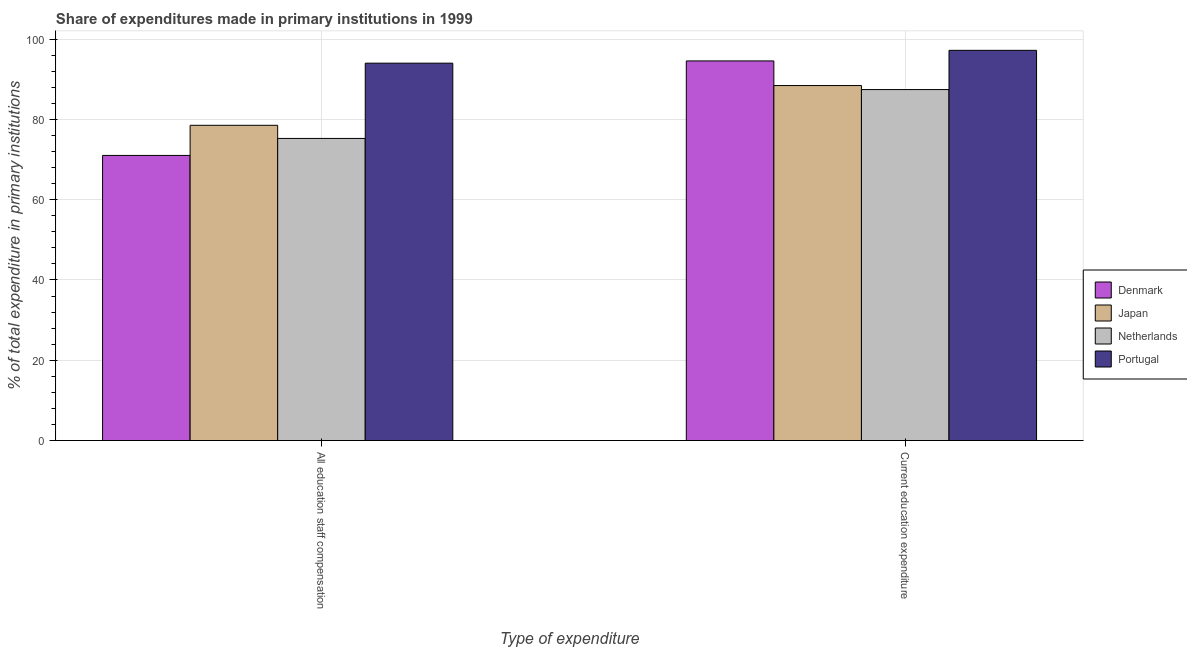How many different coloured bars are there?
Give a very brief answer. 4. How many groups of bars are there?
Offer a terse response. 2. Are the number of bars per tick equal to the number of legend labels?
Give a very brief answer. Yes. Are the number of bars on each tick of the X-axis equal?
Ensure brevity in your answer.  Yes. How many bars are there on the 2nd tick from the left?
Your answer should be very brief. 4. How many bars are there on the 1st tick from the right?
Offer a very short reply. 4. What is the label of the 2nd group of bars from the left?
Your answer should be compact. Current education expenditure. What is the expenditure in education in Portugal?
Offer a very short reply. 97.19. Across all countries, what is the maximum expenditure in staff compensation?
Give a very brief answer. 93.99. Across all countries, what is the minimum expenditure in staff compensation?
Provide a succinct answer. 71.01. In which country was the expenditure in staff compensation maximum?
Give a very brief answer. Portugal. What is the total expenditure in education in the graph?
Offer a very short reply. 367.57. What is the difference between the expenditure in education in Portugal and that in Denmark?
Provide a short and direct response. 2.64. What is the difference between the expenditure in education in Portugal and the expenditure in staff compensation in Denmark?
Your response must be concise. 26.17. What is the average expenditure in staff compensation per country?
Offer a terse response. 79.69. What is the difference between the expenditure in education and expenditure in staff compensation in Portugal?
Your answer should be very brief. 3.19. In how many countries, is the expenditure in education greater than 12 %?
Ensure brevity in your answer.  4. What is the ratio of the expenditure in education in Japan to that in Denmark?
Provide a short and direct response. 0.94. Is the expenditure in education in Denmark less than that in Japan?
Offer a very short reply. No. What does the 1st bar from the left in Current education expenditure represents?
Your answer should be very brief. Denmark. What does the 4th bar from the right in All education staff compensation represents?
Provide a short and direct response. Denmark. How many bars are there?
Your answer should be compact. 8. Does the graph contain any zero values?
Offer a terse response. No. Does the graph contain grids?
Provide a short and direct response. Yes. Where does the legend appear in the graph?
Your answer should be very brief. Center right. How many legend labels are there?
Provide a succinct answer. 4. What is the title of the graph?
Your answer should be very brief. Share of expenditures made in primary institutions in 1999. Does "Latin America(all income levels)" appear as one of the legend labels in the graph?
Keep it short and to the point. No. What is the label or title of the X-axis?
Keep it short and to the point. Type of expenditure. What is the label or title of the Y-axis?
Provide a short and direct response. % of total expenditure in primary institutions. What is the % of total expenditure in primary institutions of Denmark in All education staff compensation?
Your answer should be very brief. 71.01. What is the % of total expenditure in primary institutions in Japan in All education staff compensation?
Offer a very short reply. 78.52. What is the % of total expenditure in primary institutions of Netherlands in All education staff compensation?
Keep it short and to the point. 75.25. What is the % of total expenditure in primary institutions of Portugal in All education staff compensation?
Your answer should be compact. 93.99. What is the % of total expenditure in primary institutions in Denmark in Current education expenditure?
Offer a very short reply. 94.55. What is the % of total expenditure in primary institutions of Japan in Current education expenditure?
Make the answer very short. 88.42. What is the % of total expenditure in primary institutions of Netherlands in Current education expenditure?
Keep it short and to the point. 87.41. What is the % of total expenditure in primary institutions of Portugal in Current education expenditure?
Your answer should be very brief. 97.19. Across all Type of expenditure, what is the maximum % of total expenditure in primary institutions in Denmark?
Keep it short and to the point. 94.55. Across all Type of expenditure, what is the maximum % of total expenditure in primary institutions in Japan?
Keep it short and to the point. 88.42. Across all Type of expenditure, what is the maximum % of total expenditure in primary institutions in Netherlands?
Give a very brief answer. 87.41. Across all Type of expenditure, what is the maximum % of total expenditure in primary institutions in Portugal?
Offer a terse response. 97.19. Across all Type of expenditure, what is the minimum % of total expenditure in primary institutions of Denmark?
Your answer should be compact. 71.01. Across all Type of expenditure, what is the minimum % of total expenditure in primary institutions of Japan?
Give a very brief answer. 78.52. Across all Type of expenditure, what is the minimum % of total expenditure in primary institutions of Netherlands?
Give a very brief answer. 75.25. Across all Type of expenditure, what is the minimum % of total expenditure in primary institutions in Portugal?
Offer a very short reply. 93.99. What is the total % of total expenditure in primary institutions of Denmark in the graph?
Your answer should be compact. 165.56. What is the total % of total expenditure in primary institutions of Japan in the graph?
Ensure brevity in your answer.  166.94. What is the total % of total expenditure in primary institutions of Netherlands in the graph?
Offer a very short reply. 162.66. What is the total % of total expenditure in primary institutions in Portugal in the graph?
Make the answer very short. 191.18. What is the difference between the % of total expenditure in primary institutions in Denmark in All education staff compensation and that in Current education expenditure?
Ensure brevity in your answer.  -23.54. What is the difference between the % of total expenditure in primary institutions of Japan in All education staff compensation and that in Current education expenditure?
Provide a short and direct response. -9.9. What is the difference between the % of total expenditure in primary institutions in Netherlands in All education staff compensation and that in Current education expenditure?
Keep it short and to the point. -12.17. What is the difference between the % of total expenditure in primary institutions in Portugal in All education staff compensation and that in Current education expenditure?
Your answer should be compact. -3.19. What is the difference between the % of total expenditure in primary institutions in Denmark in All education staff compensation and the % of total expenditure in primary institutions in Japan in Current education expenditure?
Offer a very short reply. -17.41. What is the difference between the % of total expenditure in primary institutions of Denmark in All education staff compensation and the % of total expenditure in primary institutions of Netherlands in Current education expenditure?
Ensure brevity in your answer.  -16.4. What is the difference between the % of total expenditure in primary institutions of Denmark in All education staff compensation and the % of total expenditure in primary institutions of Portugal in Current education expenditure?
Your response must be concise. -26.17. What is the difference between the % of total expenditure in primary institutions in Japan in All education staff compensation and the % of total expenditure in primary institutions in Netherlands in Current education expenditure?
Offer a terse response. -8.9. What is the difference between the % of total expenditure in primary institutions in Japan in All education staff compensation and the % of total expenditure in primary institutions in Portugal in Current education expenditure?
Your answer should be compact. -18.67. What is the difference between the % of total expenditure in primary institutions in Netherlands in All education staff compensation and the % of total expenditure in primary institutions in Portugal in Current education expenditure?
Offer a terse response. -21.94. What is the average % of total expenditure in primary institutions in Denmark per Type of expenditure?
Give a very brief answer. 82.78. What is the average % of total expenditure in primary institutions of Japan per Type of expenditure?
Ensure brevity in your answer.  83.47. What is the average % of total expenditure in primary institutions of Netherlands per Type of expenditure?
Offer a very short reply. 81.33. What is the average % of total expenditure in primary institutions in Portugal per Type of expenditure?
Make the answer very short. 95.59. What is the difference between the % of total expenditure in primary institutions in Denmark and % of total expenditure in primary institutions in Japan in All education staff compensation?
Your response must be concise. -7.5. What is the difference between the % of total expenditure in primary institutions in Denmark and % of total expenditure in primary institutions in Netherlands in All education staff compensation?
Your answer should be very brief. -4.23. What is the difference between the % of total expenditure in primary institutions of Denmark and % of total expenditure in primary institutions of Portugal in All education staff compensation?
Your answer should be very brief. -22.98. What is the difference between the % of total expenditure in primary institutions in Japan and % of total expenditure in primary institutions in Netherlands in All education staff compensation?
Offer a terse response. 3.27. What is the difference between the % of total expenditure in primary institutions of Japan and % of total expenditure in primary institutions of Portugal in All education staff compensation?
Give a very brief answer. -15.48. What is the difference between the % of total expenditure in primary institutions in Netherlands and % of total expenditure in primary institutions in Portugal in All education staff compensation?
Your answer should be compact. -18.74. What is the difference between the % of total expenditure in primary institutions of Denmark and % of total expenditure in primary institutions of Japan in Current education expenditure?
Give a very brief answer. 6.13. What is the difference between the % of total expenditure in primary institutions in Denmark and % of total expenditure in primary institutions in Netherlands in Current education expenditure?
Keep it short and to the point. 7.14. What is the difference between the % of total expenditure in primary institutions of Denmark and % of total expenditure in primary institutions of Portugal in Current education expenditure?
Provide a succinct answer. -2.64. What is the difference between the % of total expenditure in primary institutions in Japan and % of total expenditure in primary institutions in Netherlands in Current education expenditure?
Provide a succinct answer. 1.01. What is the difference between the % of total expenditure in primary institutions of Japan and % of total expenditure in primary institutions of Portugal in Current education expenditure?
Your answer should be very brief. -8.77. What is the difference between the % of total expenditure in primary institutions of Netherlands and % of total expenditure in primary institutions of Portugal in Current education expenditure?
Give a very brief answer. -9.77. What is the ratio of the % of total expenditure in primary institutions in Denmark in All education staff compensation to that in Current education expenditure?
Provide a succinct answer. 0.75. What is the ratio of the % of total expenditure in primary institutions in Japan in All education staff compensation to that in Current education expenditure?
Provide a succinct answer. 0.89. What is the ratio of the % of total expenditure in primary institutions of Netherlands in All education staff compensation to that in Current education expenditure?
Provide a succinct answer. 0.86. What is the ratio of the % of total expenditure in primary institutions in Portugal in All education staff compensation to that in Current education expenditure?
Your answer should be compact. 0.97. What is the difference between the highest and the second highest % of total expenditure in primary institutions in Denmark?
Provide a short and direct response. 23.54. What is the difference between the highest and the second highest % of total expenditure in primary institutions of Japan?
Give a very brief answer. 9.9. What is the difference between the highest and the second highest % of total expenditure in primary institutions in Netherlands?
Your answer should be compact. 12.17. What is the difference between the highest and the second highest % of total expenditure in primary institutions in Portugal?
Ensure brevity in your answer.  3.19. What is the difference between the highest and the lowest % of total expenditure in primary institutions in Denmark?
Make the answer very short. 23.54. What is the difference between the highest and the lowest % of total expenditure in primary institutions of Japan?
Keep it short and to the point. 9.9. What is the difference between the highest and the lowest % of total expenditure in primary institutions in Netherlands?
Offer a very short reply. 12.17. What is the difference between the highest and the lowest % of total expenditure in primary institutions of Portugal?
Offer a terse response. 3.19. 